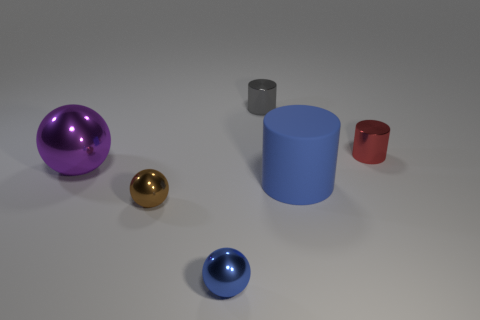Subtract all metallic cylinders. How many cylinders are left? 1 Add 3 small gray matte objects. How many objects exist? 9 Subtract all blue cylinders. How many cylinders are left? 2 Subtract 2 cylinders. How many cylinders are left? 1 Subtract all red spheres. Subtract all cyan blocks. How many spheres are left? 3 Subtract all blue cubes. How many purple spheres are left? 1 Subtract all tiny cyan matte things. Subtract all gray shiny cylinders. How many objects are left? 5 Add 3 gray things. How many gray things are left? 4 Add 3 red objects. How many red objects exist? 4 Subtract 0 red blocks. How many objects are left? 6 